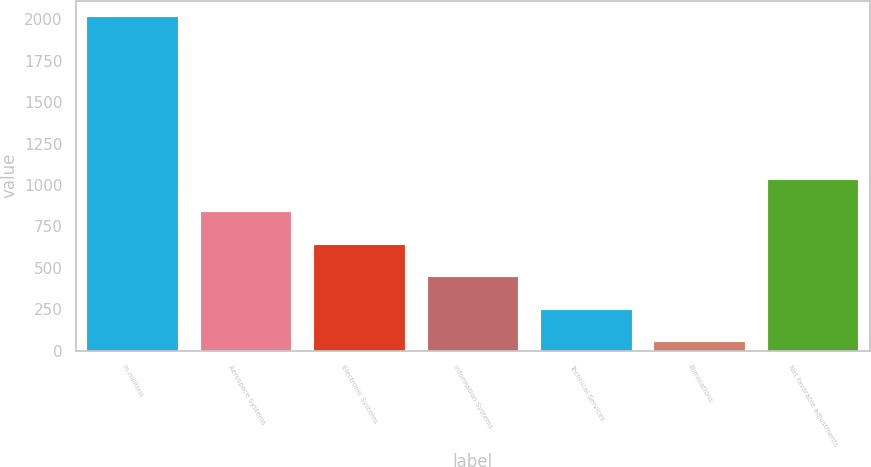<chart> <loc_0><loc_0><loc_500><loc_500><bar_chart><fcel>in millions<fcel>Aerospace Systems<fcel>Electronic Systems<fcel>Information Systems<fcel>Technical Services<fcel>Eliminations<fcel>Net favorable adjustments<nl><fcel>2012<fcel>834.8<fcel>638.6<fcel>442.4<fcel>246.2<fcel>50<fcel>1031<nl></chart> 